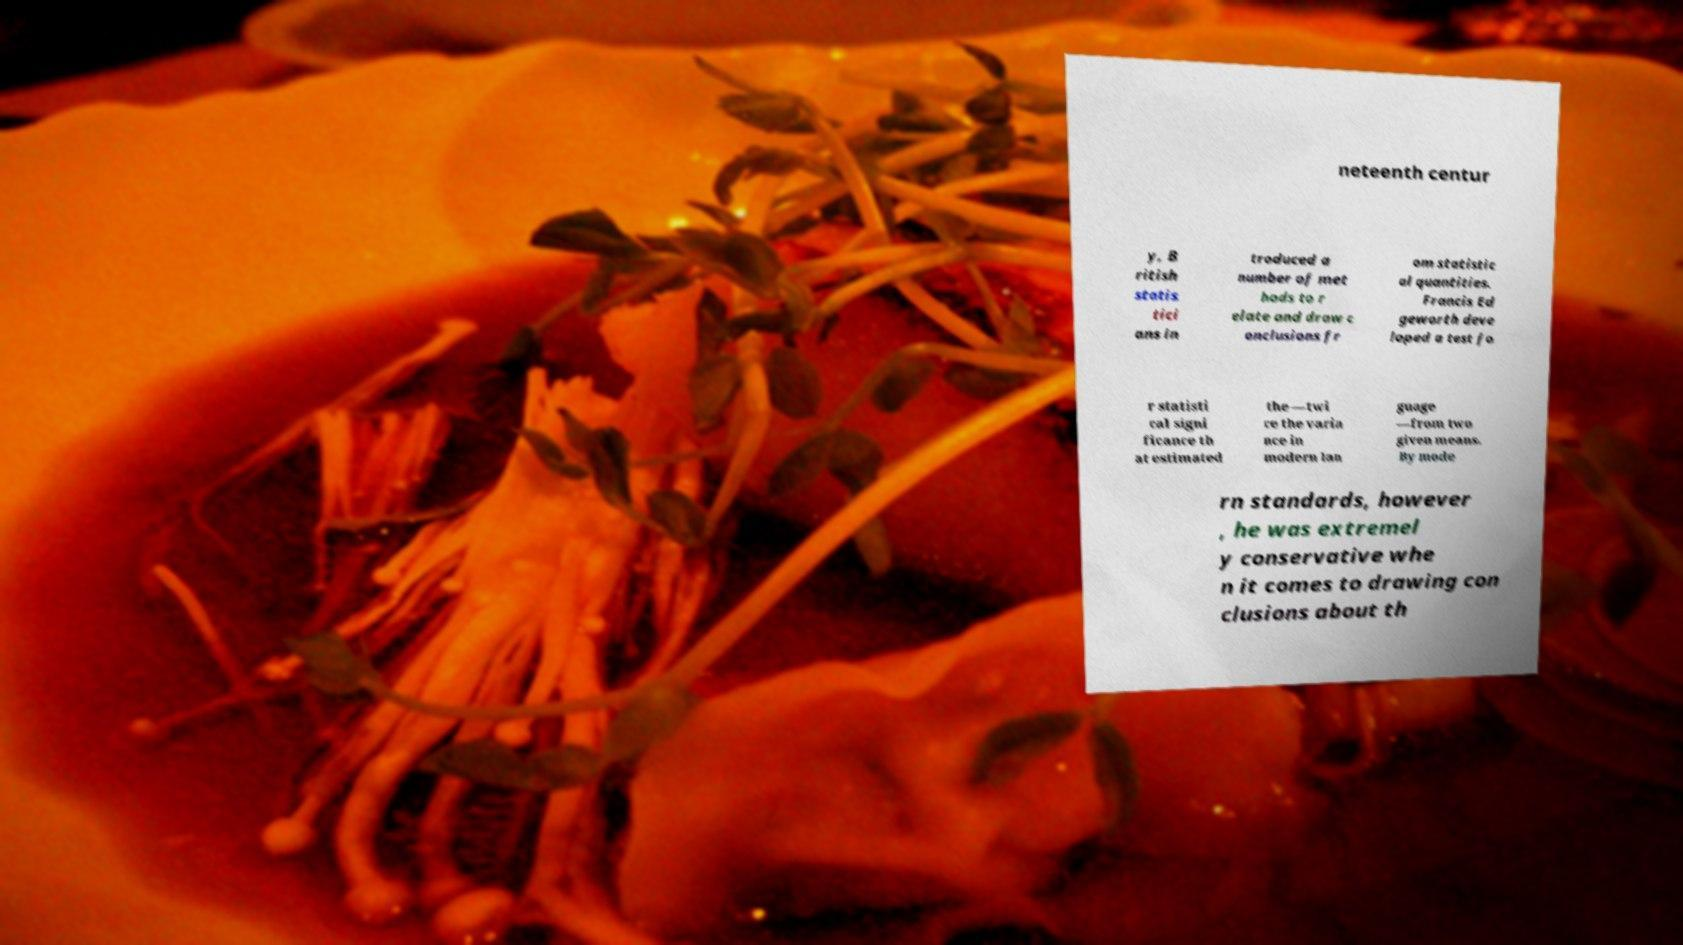I need the written content from this picture converted into text. Can you do that? neteenth centur y, B ritish statis tici ans in troduced a number of met hods to r elate and draw c onclusions fr om statistic al quantities. Francis Ed geworth deve loped a test fo r statisti cal signi ficance th at estimated the —twi ce the varia nce in modern lan guage —from two given means. By mode rn standards, however , he was extremel y conservative whe n it comes to drawing con clusions about th 